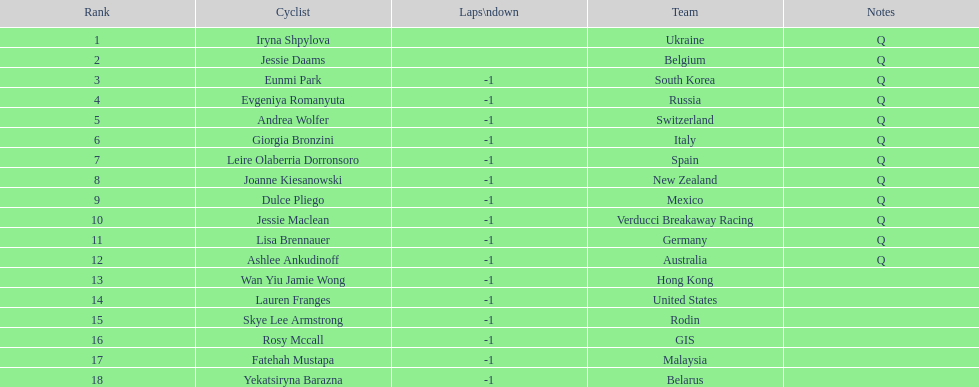Who is the last cyclist listed? Yekatsiryna Barazna. 